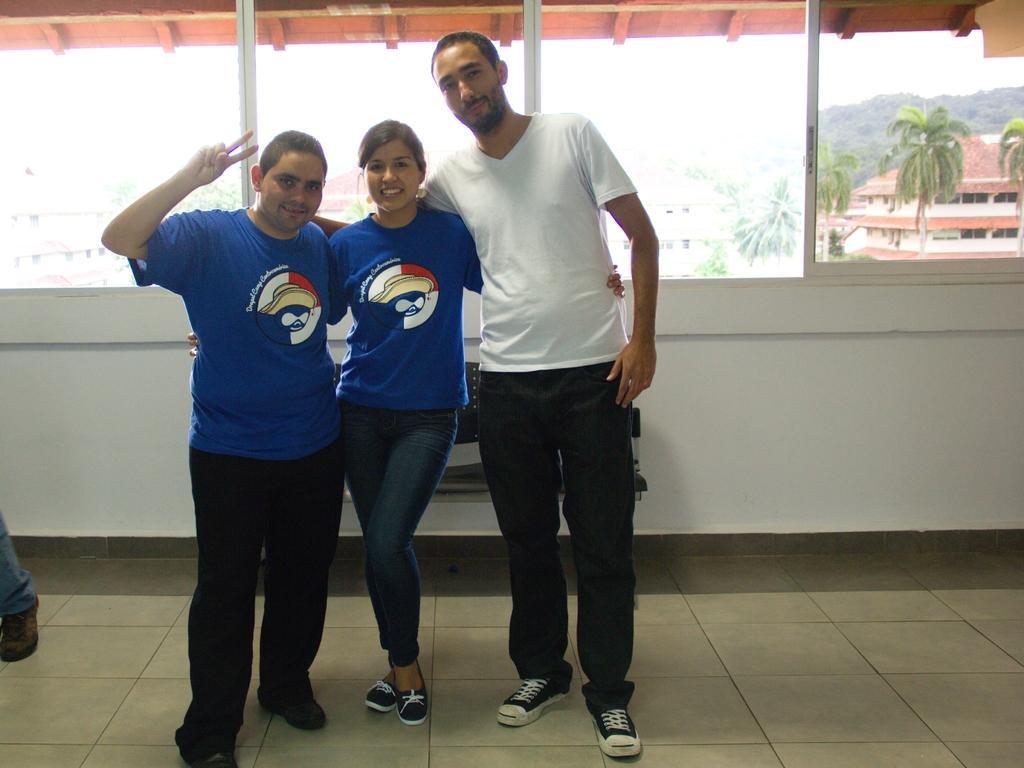Can you describe this image briefly? In this picture there are three persons in the center. A man towards the left, he is wearing a blue t shirt and a black trousers. A woman in the middle, she is wearing a blue t shirt and jeans. A man towards the right, he is wearing a white t shirt and black trousers. In the background there are windows, through one window there are buildings and trees. 